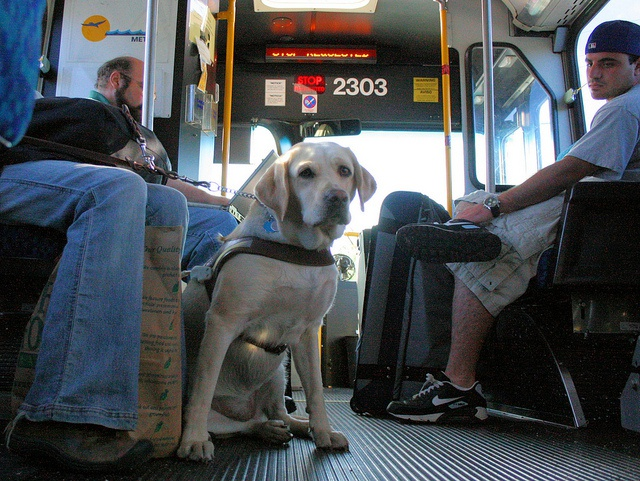Describe the objects in this image and their specific colors. I can see bus in blue, black, white, gray, and darkgray tones, people in blue, black, navy, and gray tones, dog in blue, gray, black, and darkgray tones, people in blue, black, gray, and maroon tones, and suitcase in blue, black, and gray tones in this image. 